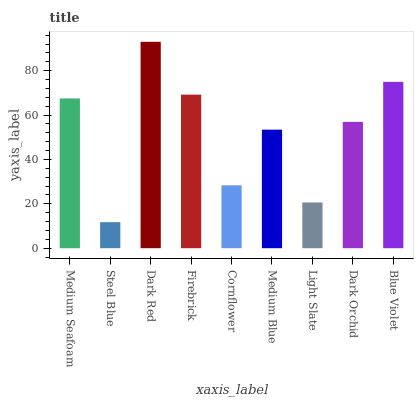Is Steel Blue the minimum?
Answer yes or no. Yes. Is Dark Red the maximum?
Answer yes or no. Yes. Is Dark Red the minimum?
Answer yes or no. No. Is Steel Blue the maximum?
Answer yes or no. No. Is Dark Red greater than Steel Blue?
Answer yes or no. Yes. Is Steel Blue less than Dark Red?
Answer yes or no. Yes. Is Steel Blue greater than Dark Red?
Answer yes or no. No. Is Dark Red less than Steel Blue?
Answer yes or no. No. Is Dark Orchid the high median?
Answer yes or no. Yes. Is Dark Orchid the low median?
Answer yes or no. Yes. Is Cornflower the high median?
Answer yes or no. No. Is Medium Blue the low median?
Answer yes or no. No. 